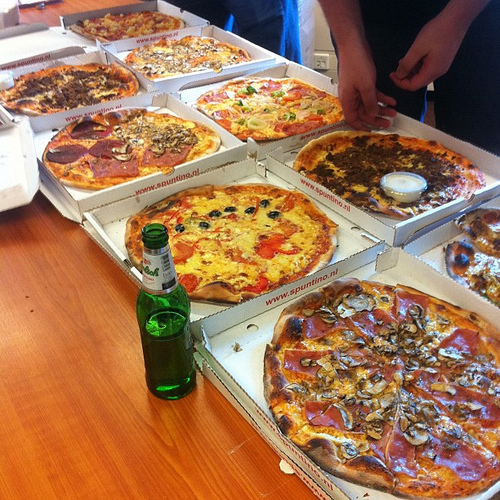Are there any boxes to the left of the vegetable in the top of the photo? Yes, there are boxes to the left of the vegetable in the top of the photo. 